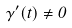<formula> <loc_0><loc_0><loc_500><loc_500>\gamma ^ { \prime } ( t ) \ne 0</formula> 